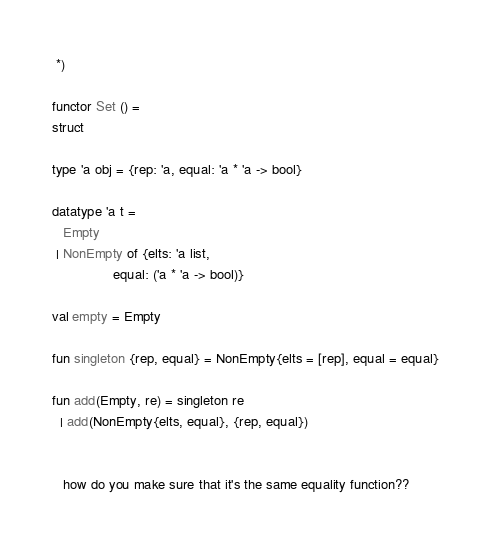<code> <loc_0><loc_0><loc_500><loc_500><_SML_> *)

functor Set () =
struct

type 'a obj = {rep: 'a, equal: 'a * 'a -> bool}

datatype 'a t =
   Empty
 | NonEmpty of {elts: 'a list,
                equal: ('a * 'a -> bool)}

val empty = Empty

fun singleton {rep, equal} = NonEmpty{elts = [rep], equal = equal}

fun add(Empty, re) = singleton re
  | add(NonEmpty{elts, equal}, {rep, equal})


   how do you make sure that it's the same equality function??
</code> 